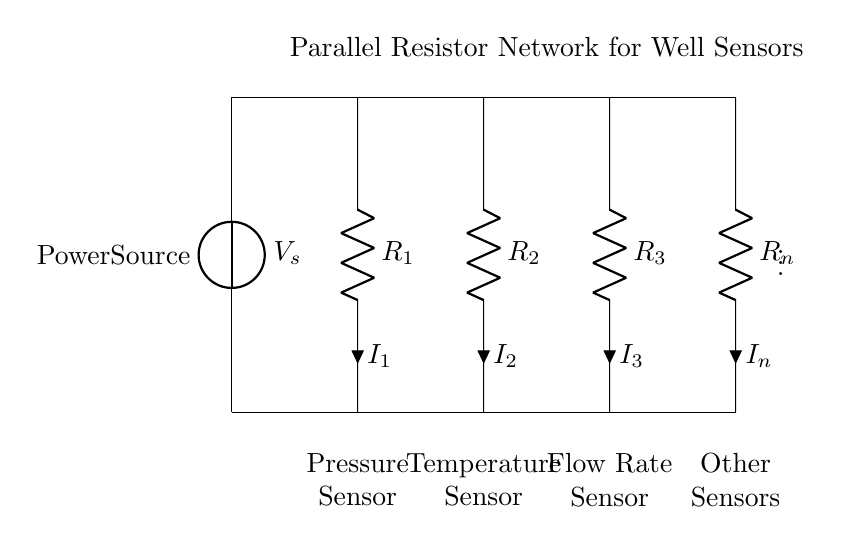What type of circuit is shown? The circuit is a parallel resistor network because multiple resistors are connected alongside each other across the same voltage source.
Answer: Parallel resistor network What is the voltage supplied to the circuit? The voltage supplied is indicated by the voltage source labeled \( V_s \) located in the circuit diagram.
Answer: \( V_s \) How many resistors are present in the circuit? There are four resistors in total labeled as \( R_1 \), \( R_2 \), \( R_3 \), and \( R_n \).
Answer: Four Which sensor is connected to \( R_2 \)? The resistor \( R_2 \) is connected to the temperature sensor, as indicated by the label below the resistor in the diagram.
Answer: Temperature Sensor What happens to the total current when more resistors are added in parallel? Adding more resistors in parallel decreases the total resistance of the circuit, which will increase the total current flowing from the power source according to Ohm's Law.
Answer: Total current increases How can you find the current through \( R_1 \)? To find the current through \( R_1 \), use the current divider rule, which states that the current through a resistor in parallel is equal to the total current multiplied by the ratio of the other parallel resistors over the total resistance of the circuit.
Answer: Use current divider rule What does the current division in this circuit imply for the sensors? The current division implies that each sensor connected to the resistors receives a different amount of current based on the resistance value of the corresponding resistor. The higher the resistance, the lower the current through that sensor, affecting its output.
Answer: Different current for each sensor 